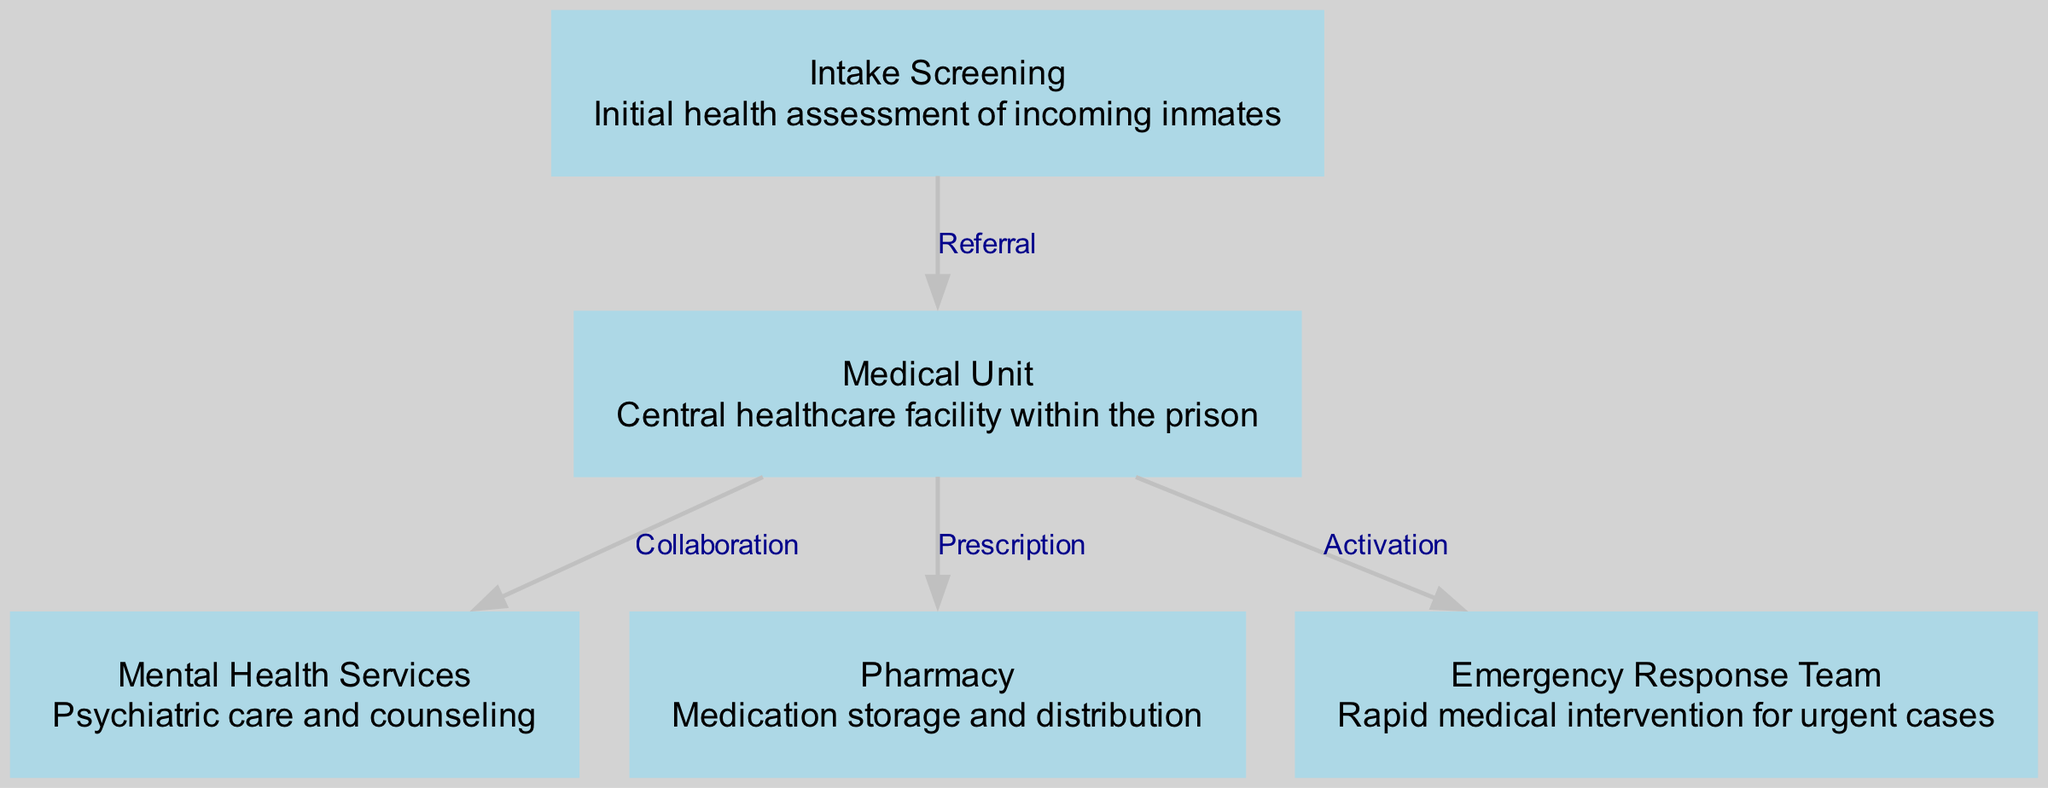What is the first step in the healthcare process for incoming inmates? The diagram indicates that the first step is "Intake Screening," which is the initial health assessment of incoming inmates.
Answer: Intake Screening How many nodes are there in the diagram? By counting the nodes listed in the data, there are five nodes representing different components of the healthcare system.
Answer: 5 What type of service is "Mental Health Services"? The diagram describes the "Mental Health Services" as providing psychiatric care and counseling, which is a specific type of healthcare service.
Answer: Psychiatric care and counseling What is the relationship between "Medical Unit" and "Emergency Response Team"? The diagram shows an "Activation" relationship from the "Medical Unit" to the "Emergency Response Team," indicating that the medical unit initiates the emergency response when urgent cases arise.
Answer: Activation Which node directly follows "Intake Screening"? The diagram indicates a "Referral" from "Intake Screening" to the "Medical Unit," meaning that the immediate follow-up after screening is the medical unit.
Answer: Medical Unit Which node is connected to the "Pharmacy"? The diagram shows that the "Pharmacy" is connected to the "Medical Unit" with a "Prescription" relationship, indicating that the medical unit prescribes medications that the pharmacy will handle.
Answer: Medical Unit What service does "Emergency Response Team" provide? The "Emergency Response Team" is specifically responsible for rapid medical intervention for urgent cases as depicted in the diagram.
Answer: Rapid medical intervention How does the "Medical Unit" collaborate with "Mental Health Services"? The diagram indicates a "Collaboration" relationship between the "Medical Unit" and "Mental Health Services," showing that they work together in addressing the healthcare needs of inmates.
Answer: Collaboration What is the primary role of the "Pharmacy" in the diagram? The diagram defines the primary role of the "Pharmacy" as medication storage and distribution, emphasizing its function in managing inmate prescriptions.
Answer: Medication storage and distribution 